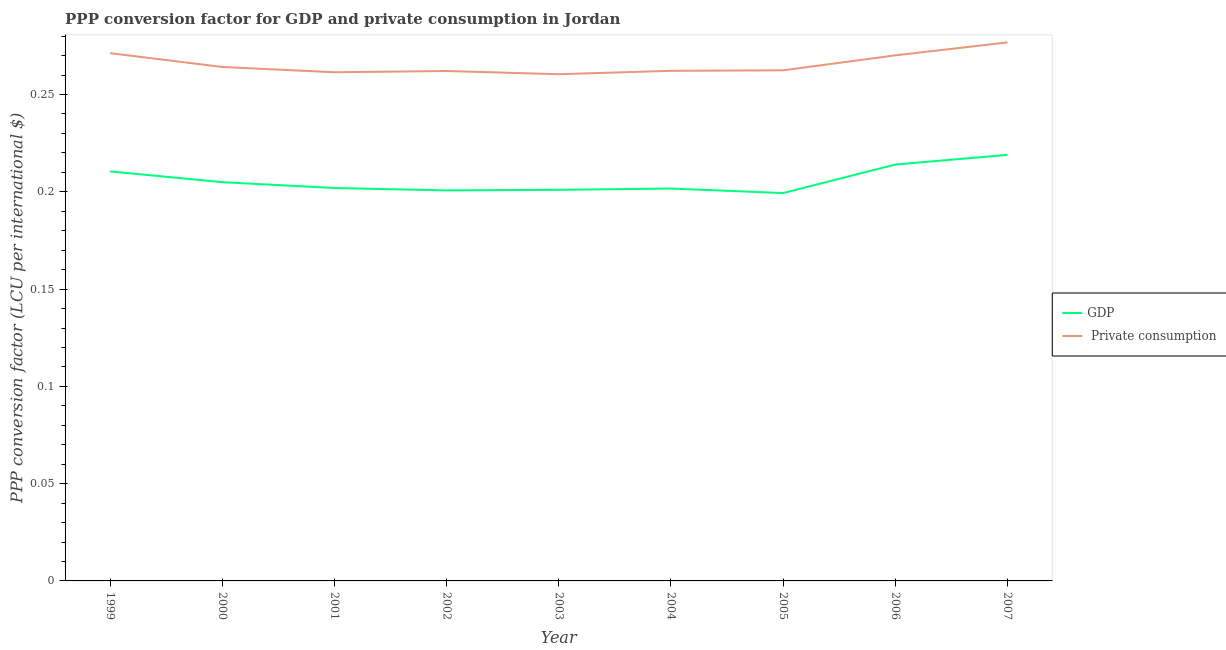How many different coloured lines are there?
Your response must be concise. 2. Does the line corresponding to ppp conversion factor for gdp intersect with the line corresponding to ppp conversion factor for private consumption?
Make the answer very short. No. What is the ppp conversion factor for private consumption in 1999?
Keep it short and to the point. 0.27. Across all years, what is the maximum ppp conversion factor for private consumption?
Your response must be concise. 0.28. Across all years, what is the minimum ppp conversion factor for gdp?
Provide a succinct answer. 0.2. What is the total ppp conversion factor for gdp in the graph?
Provide a short and direct response. 1.85. What is the difference between the ppp conversion factor for gdp in 2000 and that in 2004?
Ensure brevity in your answer.  0. What is the difference between the ppp conversion factor for gdp in 2003 and the ppp conversion factor for private consumption in 2006?
Ensure brevity in your answer.  -0.07. What is the average ppp conversion factor for gdp per year?
Offer a very short reply. 0.21. In the year 2003, what is the difference between the ppp conversion factor for gdp and ppp conversion factor for private consumption?
Provide a succinct answer. -0.06. What is the ratio of the ppp conversion factor for gdp in 2002 to that in 2004?
Offer a very short reply. 1. Is the difference between the ppp conversion factor for gdp in 2001 and 2007 greater than the difference between the ppp conversion factor for private consumption in 2001 and 2007?
Ensure brevity in your answer.  No. What is the difference between the highest and the second highest ppp conversion factor for gdp?
Keep it short and to the point. 0. What is the difference between the highest and the lowest ppp conversion factor for private consumption?
Your response must be concise. 0.02. Is the sum of the ppp conversion factor for private consumption in 2000 and 2007 greater than the maximum ppp conversion factor for gdp across all years?
Give a very brief answer. Yes. Is the ppp conversion factor for gdp strictly less than the ppp conversion factor for private consumption over the years?
Ensure brevity in your answer.  Yes. How many years are there in the graph?
Offer a very short reply. 9. Are the values on the major ticks of Y-axis written in scientific E-notation?
Offer a very short reply. No. Does the graph contain any zero values?
Your answer should be compact. No. Where does the legend appear in the graph?
Give a very brief answer. Center right. How many legend labels are there?
Offer a terse response. 2. How are the legend labels stacked?
Your answer should be very brief. Vertical. What is the title of the graph?
Your answer should be compact. PPP conversion factor for GDP and private consumption in Jordan. What is the label or title of the Y-axis?
Give a very brief answer. PPP conversion factor (LCU per international $). What is the PPP conversion factor (LCU per international $) in GDP in 1999?
Provide a succinct answer. 0.21. What is the PPP conversion factor (LCU per international $) of  Private consumption in 1999?
Provide a succinct answer. 0.27. What is the PPP conversion factor (LCU per international $) in GDP in 2000?
Your response must be concise. 0.2. What is the PPP conversion factor (LCU per international $) in  Private consumption in 2000?
Your response must be concise. 0.26. What is the PPP conversion factor (LCU per international $) in GDP in 2001?
Your response must be concise. 0.2. What is the PPP conversion factor (LCU per international $) of  Private consumption in 2001?
Your answer should be compact. 0.26. What is the PPP conversion factor (LCU per international $) of GDP in 2002?
Give a very brief answer. 0.2. What is the PPP conversion factor (LCU per international $) of  Private consumption in 2002?
Offer a very short reply. 0.26. What is the PPP conversion factor (LCU per international $) in GDP in 2003?
Offer a terse response. 0.2. What is the PPP conversion factor (LCU per international $) of  Private consumption in 2003?
Provide a succinct answer. 0.26. What is the PPP conversion factor (LCU per international $) of GDP in 2004?
Your answer should be compact. 0.2. What is the PPP conversion factor (LCU per international $) in  Private consumption in 2004?
Offer a terse response. 0.26. What is the PPP conversion factor (LCU per international $) in GDP in 2005?
Provide a short and direct response. 0.2. What is the PPP conversion factor (LCU per international $) of  Private consumption in 2005?
Your answer should be very brief. 0.26. What is the PPP conversion factor (LCU per international $) of GDP in 2006?
Provide a succinct answer. 0.21. What is the PPP conversion factor (LCU per international $) in  Private consumption in 2006?
Provide a succinct answer. 0.27. What is the PPP conversion factor (LCU per international $) in GDP in 2007?
Provide a succinct answer. 0.22. What is the PPP conversion factor (LCU per international $) in  Private consumption in 2007?
Provide a short and direct response. 0.28. Across all years, what is the maximum PPP conversion factor (LCU per international $) in GDP?
Your answer should be very brief. 0.22. Across all years, what is the maximum PPP conversion factor (LCU per international $) in  Private consumption?
Your answer should be very brief. 0.28. Across all years, what is the minimum PPP conversion factor (LCU per international $) in GDP?
Give a very brief answer. 0.2. Across all years, what is the minimum PPP conversion factor (LCU per international $) in  Private consumption?
Provide a succinct answer. 0.26. What is the total PPP conversion factor (LCU per international $) in GDP in the graph?
Offer a terse response. 1.85. What is the total PPP conversion factor (LCU per international $) in  Private consumption in the graph?
Keep it short and to the point. 2.39. What is the difference between the PPP conversion factor (LCU per international $) of GDP in 1999 and that in 2000?
Keep it short and to the point. 0.01. What is the difference between the PPP conversion factor (LCU per international $) of  Private consumption in 1999 and that in 2000?
Keep it short and to the point. 0.01. What is the difference between the PPP conversion factor (LCU per international $) in GDP in 1999 and that in 2001?
Ensure brevity in your answer.  0.01. What is the difference between the PPP conversion factor (LCU per international $) of  Private consumption in 1999 and that in 2001?
Your answer should be very brief. 0.01. What is the difference between the PPP conversion factor (LCU per international $) in GDP in 1999 and that in 2002?
Offer a very short reply. 0.01. What is the difference between the PPP conversion factor (LCU per international $) in  Private consumption in 1999 and that in 2002?
Provide a short and direct response. 0.01. What is the difference between the PPP conversion factor (LCU per international $) in GDP in 1999 and that in 2003?
Provide a succinct answer. 0.01. What is the difference between the PPP conversion factor (LCU per international $) of  Private consumption in 1999 and that in 2003?
Offer a terse response. 0.01. What is the difference between the PPP conversion factor (LCU per international $) in GDP in 1999 and that in 2004?
Your response must be concise. 0.01. What is the difference between the PPP conversion factor (LCU per international $) in  Private consumption in 1999 and that in 2004?
Your answer should be compact. 0.01. What is the difference between the PPP conversion factor (LCU per international $) in GDP in 1999 and that in 2005?
Make the answer very short. 0.01. What is the difference between the PPP conversion factor (LCU per international $) of  Private consumption in 1999 and that in 2005?
Offer a very short reply. 0.01. What is the difference between the PPP conversion factor (LCU per international $) in GDP in 1999 and that in 2006?
Offer a very short reply. -0. What is the difference between the PPP conversion factor (LCU per international $) in  Private consumption in 1999 and that in 2006?
Your response must be concise. 0. What is the difference between the PPP conversion factor (LCU per international $) of GDP in 1999 and that in 2007?
Provide a succinct answer. -0.01. What is the difference between the PPP conversion factor (LCU per international $) in  Private consumption in 1999 and that in 2007?
Ensure brevity in your answer.  -0.01. What is the difference between the PPP conversion factor (LCU per international $) of GDP in 2000 and that in 2001?
Your answer should be compact. 0. What is the difference between the PPP conversion factor (LCU per international $) in  Private consumption in 2000 and that in 2001?
Offer a terse response. 0. What is the difference between the PPP conversion factor (LCU per international $) of GDP in 2000 and that in 2002?
Your answer should be compact. 0. What is the difference between the PPP conversion factor (LCU per international $) of  Private consumption in 2000 and that in 2002?
Your answer should be compact. 0. What is the difference between the PPP conversion factor (LCU per international $) of GDP in 2000 and that in 2003?
Your response must be concise. 0. What is the difference between the PPP conversion factor (LCU per international $) of  Private consumption in 2000 and that in 2003?
Keep it short and to the point. 0. What is the difference between the PPP conversion factor (LCU per international $) in GDP in 2000 and that in 2004?
Offer a very short reply. 0. What is the difference between the PPP conversion factor (LCU per international $) in  Private consumption in 2000 and that in 2004?
Your answer should be very brief. 0. What is the difference between the PPP conversion factor (LCU per international $) in GDP in 2000 and that in 2005?
Provide a succinct answer. 0.01. What is the difference between the PPP conversion factor (LCU per international $) in  Private consumption in 2000 and that in 2005?
Your answer should be compact. 0. What is the difference between the PPP conversion factor (LCU per international $) in GDP in 2000 and that in 2006?
Ensure brevity in your answer.  -0.01. What is the difference between the PPP conversion factor (LCU per international $) in  Private consumption in 2000 and that in 2006?
Make the answer very short. -0.01. What is the difference between the PPP conversion factor (LCU per international $) of GDP in 2000 and that in 2007?
Ensure brevity in your answer.  -0.01. What is the difference between the PPP conversion factor (LCU per international $) of  Private consumption in 2000 and that in 2007?
Provide a succinct answer. -0.01. What is the difference between the PPP conversion factor (LCU per international $) of GDP in 2001 and that in 2002?
Offer a terse response. 0. What is the difference between the PPP conversion factor (LCU per international $) of  Private consumption in 2001 and that in 2002?
Keep it short and to the point. -0. What is the difference between the PPP conversion factor (LCU per international $) of GDP in 2001 and that in 2003?
Provide a succinct answer. 0. What is the difference between the PPP conversion factor (LCU per international $) in  Private consumption in 2001 and that in 2004?
Provide a short and direct response. -0. What is the difference between the PPP conversion factor (LCU per international $) of GDP in 2001 and that in 2005?
Your answer should be compact. 0. What is the difference between the PPP conversion factor (LCU per international $) of  Private consumption in 2001 and that in 2005?
Provide a short and direct response. -0. What is the difference between the PPP conversion factor (LCU per international $) of GDP in 2001 and that in 2006?
Make the answer very short. -0.01. What is the difference between the PPP conversion factor (LCU per international $) in  Private consumption in 2001 and that in 2006?
Provide a succinct answer. -0.01. What is the difference between the PPP conversion factor (LCU per international $) of GDP in 2001 and that in 2007?
Keep it short and to the point. -0.02. What is the difference between the PPP conversion factor (LCU per international $) of  Private consumption in 2001 and that in 2007?
Offer a terse response. -0.02. What is the difference between the PPP conversion factor (LCU per international $) of GDP in 2002 and that in 2003?
Your answer should be very brief. -0. What is the difference between the PPP conversion factor (LCU per international $) in  Private consumption in 2002 and that in 2003?
Provide a short and direct response. 0. What is the difference between the PPP conversion factor (LCU per international $) in GDP in 2002 and that in 2004?
Make the answer very short. -0. What is the difference between the PPP conversion factor (LCU per international $) in  Private consumption in 2002 and that in 2004?
Ensure brevity in your answer.  -0. What is the difference between the PPP conversion factor (LCU per international $) in GDP in 2002 and that in 2005?
Your response must be concise. 0. What is the difference between the PPP conversion factor (LCU per international $) in  Private consumption in 2002 and that in 2005?
Provide a succinct answer. -0. What is the difference between the PPP conversion factor (LCU per international $) in GDP in 2002 and that in 2006?
Give a very brief answer. -0.01. What is the difference between the PPP conversion factor (LCU per international $) in  Private consumption in 2002 and that in 2006?
Your response must be concise. -0.01. What is the difference between the PPP conversion factor (LCU per international $) of GDP in 2002 and that in 2007?
Your answer should be very brief. -0.02. What is the difference between the PPP conversion factor (LCU per international $) in  Private consumption in 2002 and that in 2007?
Keep it short and to the point. -0.01. What is the difference between the PPP conversion factor (LCU per international $) in GDP in 2003 and that in 2004?
Offer a terse response. -0. What is the difference between the PPP conversion factor (LCU per international $) of  Private consumption in 2003 and that in 2004?
Keep it short and to the point. -0. What is the difference between the PPP conversion factor (LCU per international $) in GDP in 2003 and that in 2005?
Your answer should be very brief. 0. What is the difference between the PPP conversion factor (LCU per international $) in  Private consumption in 2003 and that in 2005?
Your response must be concise. -0. What is the difference between the PPP conversion factor (LCU per international $) in GDP in 2003 and that in 2006?
Your answer should be very brief. -0.01. What is the difference between the PPP conversion factor (LCU per international $) in  Private consumption in 2003 and that in 2006?
Provide a succinct answer. -0.01. What is the difference between the PPP conversion factor (LCU per international $) in GDP in 2003 and that in 2007?
Ensure brevity in your answer.  -0.02. What is the difference between the PPP conversion factor (LCU per international $) in  Private consumption in 2003 and that in 2007?
Your response must be concise. -0.02. What is the difference between the PPP conversion factor (LCU per international $) of GDP in 2004 and that in 2005?
Your response must be concise. 0. What is the difference between the PPP conversion factor (LCU per international $) of  Private consumption in 2004 and that in 2005?
Offer a terse response. -0. What is the difference between the PPP conversion factor (LCU per international $) of GDP in 2004 and that in 2006?
Offer a terse response. -0.01. What is the difference between the PPP conversion factor (LCU per international $) of  Private consumption in 2004 and that in 2006?
Provide a succinct answer. -0.01. What is the difference between the PPP conversion factor (LCU per international $) in GDP in 2004 and that in 2007?
Offer a terse response. -0.02. What is the difference between the PPP conversion factor (LCU per international $) in  Private consumption in 2004 and that in 2007?
Keep it short and to the point. -0.01. What is the difference between the PPP conversion factor (LCU per international $) in GDP in 2005 and that in 2006?
Provide a short and direct response. -0.01. What is the difference between the PPP conversion factor (LCU per international $) of  Private consumption in 2005 and that in 2006?
Give a very brief answer. -0.01. What is the difference between the PPP conversion factor (LCU per international $) of GDP in 2005 and that in 2007?
Your answer should be very brief. -0.02. What is the difference between the PPP conversion factor (LCU per international $) in  Private consumption in 2005 and that in 2007?
Provide a succinct answer. -0.01. What is the difference between the PPP conversion factor (LCU per international $) in GDP in 2006 and that in 2007?
Offer a very short reply. -0.01. What is the difference between the PPP conversion factor (LCU per international $) of  Private consumption in 2006 and that in 2007?
Provide a succinct answer. -0.01. What is the difference between the PPP conversion factor (LCU per international $) of GDP in 1999 and the PPP conversion factor (LCU per international $) of  Private consumption in 2000?
Provide a short and direct response. -0.05. What is the difference between the PPP conversion factor (LCU per international $) in GDP in 1999 and the PPP conversion factor (LCU per international $) in  Private consumption in 2001?
Provide a succinct answer. -0.05. What is the difference between the PPP conversion factor (LCU per international $) of GDP in 1999 and the PPP conversion factor (LCU per international $) of  Private consumption in 2002?
Keep it short and to the point. -0.05. What is the difference between the PPP conversion factor (LCU per international $) of GDP in 1999 and the PPP conversion factor (LCU per international $) of  Private consumption in 2004?
Give a very brief answer. -0.05. What is the difference between the PPP conversion factor (LCU per international $) of GDP in 1999 and the PPP conversion factor (LCU per international $) of  Private consumption in 2005?
Make the answer very short. -0.05. What is the difference between the PPP conversion factor (LCU per international $) of GDP in 1999 and the PPP conversion factor (LCU per international $) of  Private consumption in 2006?
Your response must be concise. -0.06. What is the difference between the PPP conversion factor (LCU per international $) of GDP in 1999 and the PPP conversion factor (LCU per international $) of  Private consumption in 2007?
Offer a terse response. -0.07. What is the difference between the PPP conversion factor (LCU per international $) of GDP in 2000 and the PPP conversion factor (LCU per international $) of  Private consumption in 2001?
Make the answer very short. -0.06. What is the difference between the PPP conversion factor (LCU per international $) of GDP in 2000 and the PPP conversion factor (LCU per international $) of  Private consumption in 2002?
Offer a terse response. -0.06. What is the difference between the PPP conversion factor (LCU per international $) in GDP in 2000 and the PPP conversion factor (LCU per international $) in  Private consumption in 2003?
Give a very brief answer. -0.06. What is the difference between the PPP conversion factor (LCU per international $) of GDP in 2000 and the PPP conversion factor (LCU per international $) of  Private consumption in 2004?
Make the answer very short. -0.06. What is the difference between the PPP conversion factor (LCU per international $) of GDP in 2000 and the PPP conversion factor (LCU per international $) of  Private consumption in 2005?
Your response must be concise. -0.06. What is the difference between the PPP conversion factor (LCU per international $) in GDP in 2000 and the PPP conversion factor (LCU per international $) in  Private consumption in 2006?
Your answer should be very brief. -0.07. What is the difference between the PPP conversion factor (LCU per international $) in GDP in 2000 and the PPP conversion factor (LCU per international $) in  Private consumption in 2007?
Ensure brevity in your answer.  -0.07. What is the difference between the PPP conversion factor (LCU per international $) of GDP in 2001 and the PPP conversion factor (LCU per international $) of  Private consumption in 2002?
Ensure brevity in your answer.  -0.06. What is the difference between the PPP conversion factor (LCU per international $) of GDP in 2001 and the PPP conversion factor (LCU per international $) of  Private consumption in 2003?
Your response must be concise. -0.06. What is the difference between the PPP conversion factor (LCU per international $) of GDP in 2001 and the PPP conversion factor (LCU per international $) of  Private consumption in 2004?
Offer a terse response. -0.06. What is the difference between the PPP conversion factor (LCU per international $) of GDP in 2001 and the PPP conversion factor (LCU per international $) of  Private consumption in 2005?
Provide a short and direct response. -0.06. What is the difference between the PPP conversion factor (LCU per international $) of GDP in 2001 and the PPP conversion factor (LCU per international $) of  Private consumption in 2006?
Give a very brief answer. -0.07. What is the difference between the PPP conversion factor (LCU per international $) in GDP in 2001 and the PPP conversion factor (LCU per international $) in  Private consumption in 2007?
Provide a succinct answer. -0.07. What is the difference between the PPP conversion factor (LCU per international $) in GDP in 2002 and the PPP conversion factor (LCU per international $) in  Private consumption in 2003?
Your response must be concise. -0.06. What is the difference between the PPP conversion factor (LCU per international $) in GDP in 2002 and the PPP conversion factor (LCU per international $) in  Private consumption in 2004?
Your answer should be compact. -0.06. What is the difference between the PPP conversion factor (LCU per international $) of GDP in 2002 and the PPP conversion factor (LCU per international $) of  Private consumption in 2005?
Keep it short and to the point. -0.06. What is the difference between the PPP conversion factor (LCU per international $) of GDP in 2002 and the PPP conversion factor (LCU per international $) of  Private consumption in 2006?
Make the answer very short. -0.07. What is the difference between the PPP conversion factor (LCU per international $) in GDP in 2002 and the PPP conversion factor (LCU per international $) in  Private consumption in 2007?
Offer a very short reply. -0.08. What is the difference between the PPP conversion factor (LCU per international $) of GDP in 2003 and the PPP conversion factor (LCU per international $) of  Private consumption in 2004?
Keep it short and to the point. -0.06. What is the difference between the PPP conversion factor (LCU per international $) in GDP in 2003 and the PPP conversion factor (LCU per international $) in  Private consumption in 2005?
Provide a succinct answer. -0.06. What is the difference between the PPP conversion factor (LCU per international $) in GDP in 2003 and the PPP conversion factor (LCU per international $) in  Private consumption in 2006?
Your response must be concise. -0.07. What is the difference between the PPP conversion factor (LCU per international $) in GDP in 2003 and the PPP conversion factor (LCU per international $) in  Private consumption in 2007?
Ensure brevity in your answer.  -0.08. What is the difference between the PPP conversion factor (LCU per international $) in GDP in 2004 and the PPP conversion factor (LCU per international $) in  Private consumption in 2005?
Provide a short and direct response. -0.06. What is the difference between the PPP conversion factor (LCU per international $) in GDP in 2004 and the PPP conversion factor (LCU per international $) in  Private consumption in 2006?
Your answer should be very brief. -0.07. What is the difference between the PPP conversion factor (LCU per international $) in GDP in 2004 and the PPP conversion factor (LCU per international $) in  Private consumption in 2007?
Provide a succinct answer. -0.08. What is the difference between the PPP conversion factor (LCU per international $) of GDP in 2005 and the PPP conversion factor (LCU per international $) of  Private consumption in 2006?
Give a very brief answer. -0.07. What is the difference between the PPP conversion factor (LCU per international $) in GDP in 2005 and the PPP conversion factor (LCU per international $) in  Private consumption in 2007?
Give a very brief answer. -0.08. What is the difference between the PPP conversion factor (LCU per international $) of GDP in 2006 and the PPP conversion factor (LCU per international $) of  Private consumption in 2007?
Your answer should be very brief. -0.06. What is the average PPP conversion factor (LCU per international $) of GDP per year?
Provide a succinct answer. 0.21. What is the average PPP conversion factor (LCU per international $) of  Private consumption per year?
Offer a terse response. 0.27. In the year 1999, what is the difference between the PPP conversion factor (LCU per international $) of GDP and PPP conversion factor (LCU per international $) of  Private consumption?
Your answer should be very brief. -0.06. In the year 2000, what is the difference between the PPP conversion factor (LCU per international $) of GDP and PPP conversion factor (LCU per international $) of  Private consumption?
Provide a short and direct response. -0.06. In the year 2001, what is the difference between the PPP conversion factor (LCU per international $) of GDP and PPP conversion factor (LCU per international $) of  Private consumption?
Your response must be concise. -0.06. In the year 2002, what is the difference between the PPP conversion factor (LCU per international $) in GDP and PPP conversion factor (LCU per international $) in  Private consumption?
Give a very brief answer. -0.06. In the year 2003, what is the difference between the PPP conversion factor (LCU per international $) of GDP and PPP conversion factor (LCU per international $) of  Private consumption?
Offer a very short reply. -0.06. In the year 2004, what is the difference between the PPP conversion factor (LCU per international $) in GDP and PPP conversion factor (LCU per international $) in  Private consumption?
Your response must be concise. -0.06. In the year 2005, what is the difference between the PPP conversion factor (LCU per international $) in GDP and PPP conversion factor (LCU per international $) in  Private consumption?
Offer a terse response. -0.06. In the year 2006, what is the difference between the PPP conversion factor (LCU per international $) of GDP and PPP conversion factor (LCU per international $) of  Private consumption?
Offer a terse response. -0.06. In the year 2007, what is the difference between the PPP conversion factor (LCU per international $) in GDP and PPP conversion factor (LCU per international $) in  Private consumption?
Offer a terse response. -0.06. What is the ratio of the PPP conversion factor (LCU per international $) of GDP in 1999 to that in 2000?
Offer a very short reply. 1.03. What is the ratio of the PPP conversion factor (LCU per international $) of  Private consumption in 1999 to that in 2000?
Provide a short and direct response. 1.03. What is the ratio of the PPP conversion factor (LCU per international $) of GDP in 1999 to that in 2001?
Ensure brevity in your answer.  1.04. What is the ratio of the PPP conversion factor (LCU per international $) of  Private consumption in 1999 to that in 2001?
Your response must be concise. 1.04. What is the ratio of the PPP conversion factor (LCU per international $) in GDP in 1999 to that in 2002?
Your answer should be very brief. 1.05. What is the ratio of the PPP conversion factor (LCU per international $) of  Private consumption in 1999 to that in 2002?
Your answer should be very brief. 1.03. What is the ratio of the PPP conversion factor (LCU per international $) in GDP in 1999 to that in 2003?
Make the answer very short. 1.05. What is the ratio of the PPP conversion factor (LCU per international $) in  Private consumption in 1999 to that in 2003?
Provide a succinct answer. 1.04. What is the ratio of the PPP conversion factor (LCU per international $) of GDP in 1999 to that in 2004?
Ensure brevity in your answer.  1.04. What is the ratio of the PPP conversion factor (LCU per international $) of  Private consumption in 1999 to that in 2004?
Make the answer very short. 1.03. What is the ratio of the PPP conversion factor (LCU per international $) of GDP in 1999 to that in 2005?
Keep it short and to the point. 1.06. What is the ratio of the PPP conversion factor (LCU per international $) in  Private consumption in 1999 to that in 2005?
Provide a succinct answer. 1.03. What is the ratio of the PPP conversion factor (LCU per international $) in GDP in 1999 to that in 2006?
Ensure brevity in your answer.  0.98. What is the ratio of the PPP conversion factor (LCU per international $) of GDP in 1999 to that in 2007?
Provide a succinct answer. 0.96. What is the ratio of the PPP conversion factor (LCU per international $) in  Private consumption in 1999 to that in 2007?
Your answer should be compact. 0.98. What is the ratio of the PPP conversion factor (LCU per international $) of GDP in 2000 to that in 2001?
Your answer should be very brief. 1.01. What is the ratio of the PPP conversion factor (LCU per international $) in  Private consumption in 2000 to that in 2001?
Offer a terse response. 1.01. What is the ratio of the PPP conversion factor (LCU per international $) in GDP in 2000 to that in 2002?
Your answer should be compact. 1.02. What is the ratio of the PPP conversion factor (LCU per international $) of  Private consumption in 2000 to that in 2002?
Give a very brief answer. 1.01. What is the ratio of the PPP conversion factor (LCU per international $) of GDP in 2000 to that in 2003?
Provide a succinct answer. 1.02. What is the ratio of the PPP conversion factor (LCU per international $) in  Private consumption in 2000 to that in 2003?
Provide a succinct answer. 1.01. What is the ratio of the PPP conversion factor (LCU per international $) in GDP in 2000 to that in 2004?
Provide a succinct answer. 1.02. What is the ratio of the PPP conversion factor (LCU per international $) of  Private consumption in 2000 to that in 2004?
Provide a short and direct response. 1.01. What is the ratio of the PPP conversion factor (LCU per international $) in GDP in 2000 to that in 2005?
Your response must be concise. 1.03. What is the ratio of the PPP conversion factor (LCU per international $) in  Private consumption in 2000 to that in 2005?
Your answer should be very brief. 1.01. What is the ratio of the PPP conversion factor (LCU per international $) of GDP in 2000 to that in 2006?
Your answer should be very brief. 0.96. What is the ratio of the PPP conversion factor (LCU per international $) of  Private consumption in 2000 to that in 2006?
Provide a succinct answer. 0.98. What is the ratio of the PPP conversion factor (LCU per international $) in GDP in 2000 to that in 2007?
Make the answer very short. 0.94. What is the ratio of the PPP conversion factor (LCU per international $) in  Private consumption in 2000 to that in 2007?
Offer a terse response. 0.95. What is the ratio of the PPP conversion factor (LCU per international $) in GDP in 2001 to that in 2002?
Provide a short and direct response. 1.01. What is the ratio of the PPP conversion factor (LCU per international $) of  Private consumption in 2001 to that in 2002?
Ensure brevity in your answer.  1. What is the ratio of the PPP conversion factor (LCU per international $) of  Private consumption in 2001 to that in 2003?
Offer a terse response. 1. What is the ratio of the PPP conversion factor (LCU per international $) of GDP in 2001 to that in 2004?
Provide a succinct answer. 1. What is the ratio of the PPP conversion factor (LCU per international $) of GDP in 2001 to that in 2006?
Give a very brief answer. 0.94. What is the ratio of the PPP conversion factor (LCU per international $) of  Private consumption in 2001 to that in 2006?
Make the answer very short. 0.97. What is the ratio of the PPP conversion factor (LCU per international $) of GDP in 2001 to that in 2007?
Keep it short and to the point. 0.92. What is the ratio of the PPP conversion factor (LCU per international $) of  Private consumption in 2001 to that in 2007?
Provide a short and direct response. 0.94. What is the ratio of the PPP conversion factor (LCU per international $) of  Private consumption in 2002 to that in 2003?
Your answer should be very brief. 1.01. What is the ratio of the PPP conversion factor (LCU per international $) in GDP in 2002 to that in 2004?
Offer a very short reply. 1. What is the ratio of the PPP conversion factor (LCU per international $) of  Private consumption in 2002 to that in 2004?
Give a very brief answer. 1. What is the ratio of the PPP conversion factor (LCU per international $) of GDP in 2002 to that in 2005?
Ensure brevity in your answer.  1.01. What is the ratio of the PPP conversion factor (LCU per international $) of GDP in 2002 to that in 2006?
Give a very brief answer. 0.94. What is the ratio of the PPP conversion factor (LCU per international $) in  Private consumption in 2002 to that in 2006?
Your answer should be very brief. 0.97. What is the ratio of the PPP conversion factor (LCU per international $) in GDP in 2002 to that in 2007?
Ensure brevity in your answer.  0.92. What is the ratio of the PPP conversion factor (LCU per international $) in  Private consumption in 2002 to that in 2007?
Keep it short and to the point. 0.95. What is the ratio of the PPP conversion factor (LCU per international $) in GDP in 2003 to that in 2004?
Your answer should be very brief. 1. What is the ratio of the PPP conversion factor (LCU per international $) of GDP in 2003 to that in 2005?
Your response must be concise. 1.01. What is the ratio of the PPP conversion factor (LCU per international $) in GDP in 2003 to that in 2006?
Keep it short and to the point. 0.94. What is the ratio of the PPP conversion factor (LCU per international $) in  Private consumption in 2003 to that in 2006?
Offer a very short reply. 0.96. What is the ratio of the PPP conversion factor (LCU per international $) of GDP in 2003 to that in 2007?
Provide a succinct answer. 0.92. What is the ratio of the PPP conversion factor (LCU per international $) in  Private consumption in 2003 to that in 2007?
Offer a terse response. 0.94. What is the ratio of the PPP conversion factor (LCU per international $) of GDP in 2004 to that in 2005?
Your response must be concise. 1.01. What is the ratio of the PPP conversion factor (LCU per international $) in GDP in 2004 to that in 2006?
Your answer should be very brief. 0.94. What is the ratio of the PPP conversion factor (LCU per international $) of  Private consumption in 2004 to that in 2006?
Keep it short and to the point. 0.97. What is the ratio of the PPP conversion factor (LCU per international $) of GDP in 2004 to that in 2007?
Offer a terse response. 0.92. What is the ratio of the PPP conversion factor (LCU per international $) in  Private consumption in 2004 to that in 2007?
Provide a short and direct response. 0.95. What is the ratio of the PPP conversion factor (LCU per international $) in GDP in 2005 to that in 2006?
Your answer should be very brief. 0.93. What is the ratio of the PPP conversion factor (LCU per international $) of  Private consumption in 2005 to that in 2006?
Give a very brief answer. 0.97. What is the ratio of the PPP conversion factor (LCU per international $) in GDP in 2005 to that in 2007?
Your response must be concise. 0.91. What is the ratio of the PPP conversion factor (LCU per international $) in  Private consumption in 2005 to that in 2007?
Your response must be concise. 0.95. What is the ratio of the PPP conversion factor (LCU per international $) in GDP in 2006 to that in 2007?
Make the answer very short. 0.98. What is the difference between the highest and the second highest PPP conversion factor (LCU per international $) in GDP?
Offer a very short reply. 0.01. What is the difference between the highest and the second highest PPP conversion factor (LCU per international $) in  Private consumption?
Give a very brief answer. 0.01. What is the difference between the highest and the lowest PPP conversion factor (LCU per international $) in GDP?
Your answer should be very brief. 0.02. What is the difference between the highest and the lowest PPP conversion factor (LCU per international $) in  Private consumption?
Give a very brief answer. 0.02. 